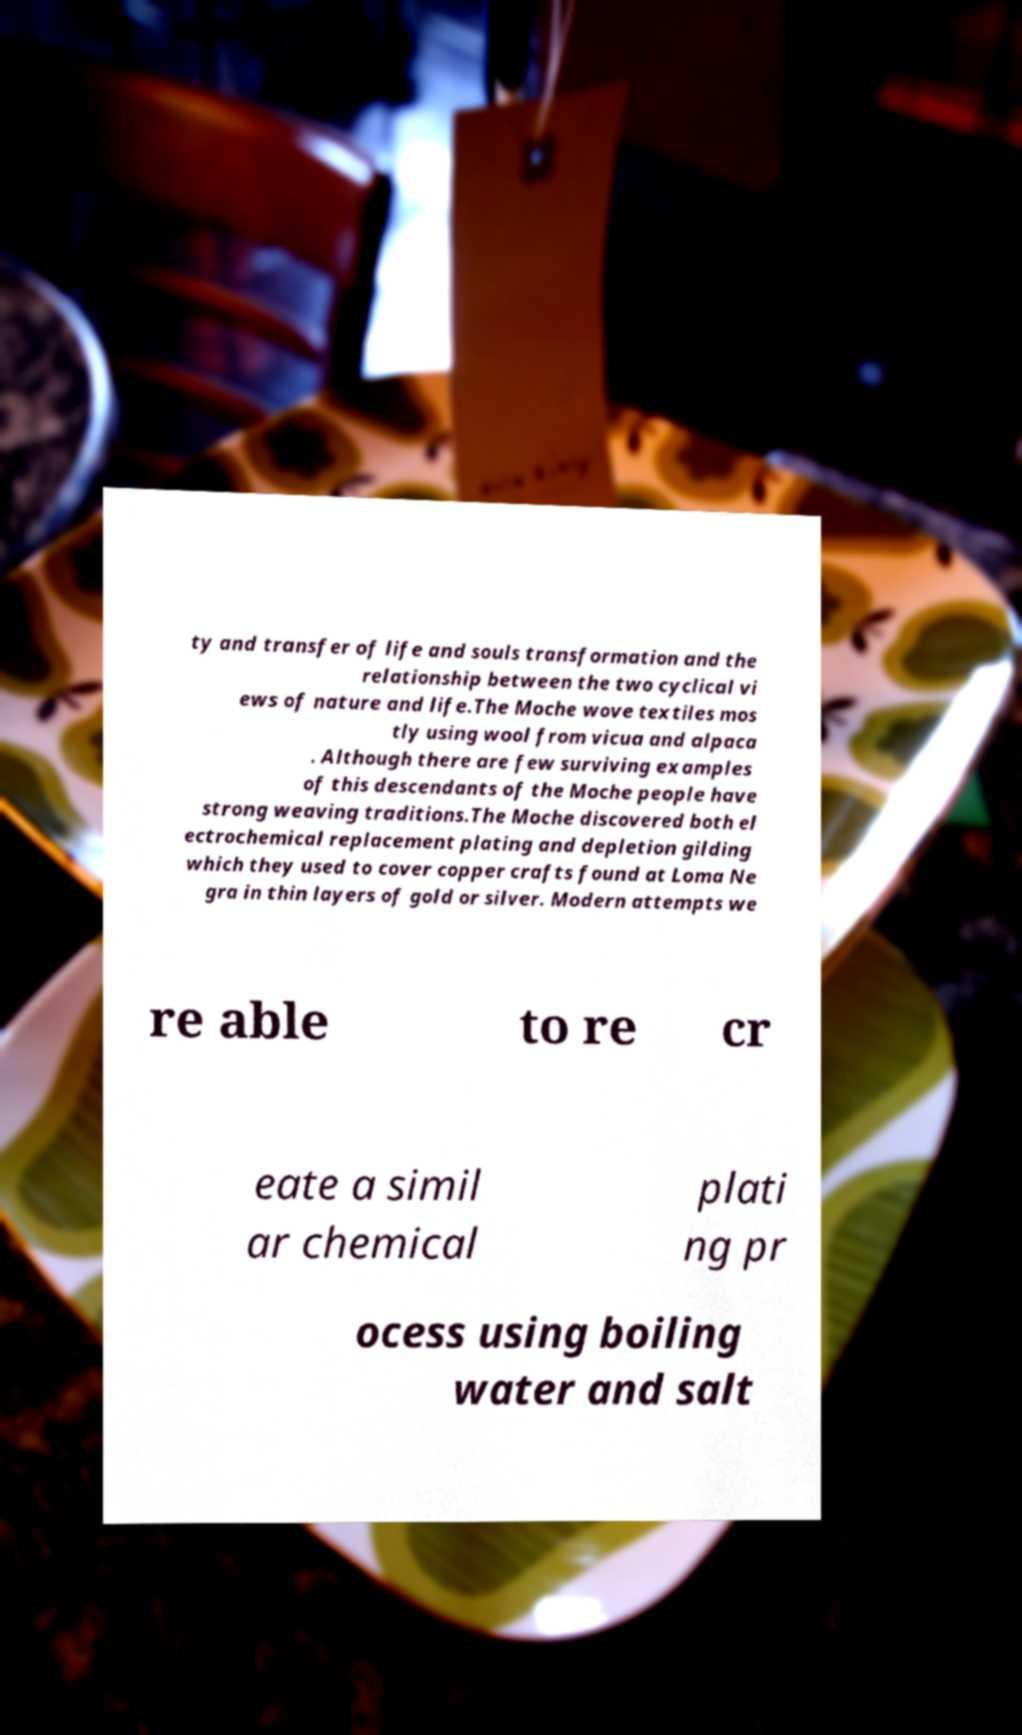Please identify and transcribe the text found in this image. ty and transfer of life and souls transformation and the relationship between the two cyclical vi ews of nature and life.The Moche wove textiles mos tly using wool from vicua and alpaca . Although there are few surviving examples of this descendants of the Moche people have strong weaving traditions.The Moche discovered both el ectrochemical replacement plating and depletion gilding which they used to cover copper crafts found at Loma Ne gra in thin layers of gold or silver. Modern attempts we re able to re cr eate a simil ar chemical plati ng pr ocess using boiling water and salt 